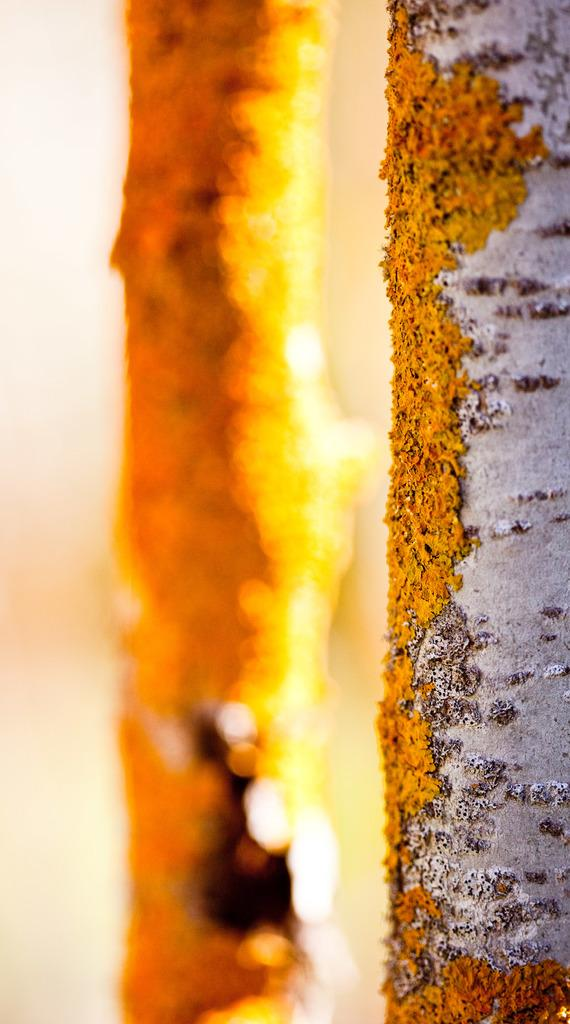What type of vegetation can be seen in the image? There are stems of trees in the image. What is the level of wealth depicted in the image? There is no indication of wealth in the image, as it only features stems of trees. 